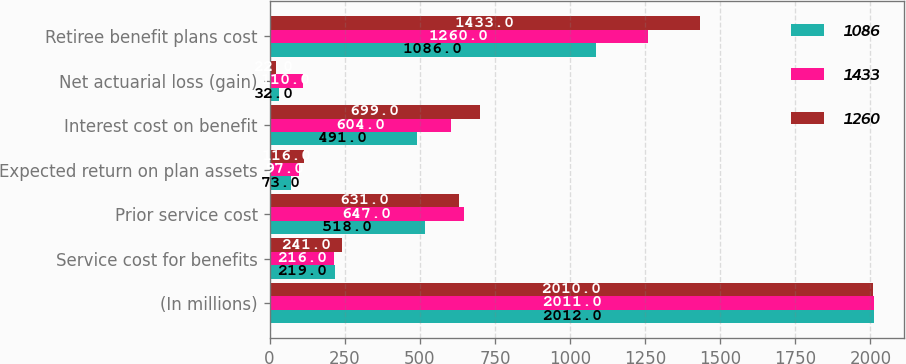<chart> <loc_0><loc_0><loc_500><loc_500><stacked_bar_chart><ecel><fcel>(In millions)<fcel>Service cost for benefits<fcel>Prior service cost<fcel>Expected return on plan assets<fcel>Interest cost on benefit<fcel>Net actuarial loss (gain)<fcel>Retiree benefit plans cost<nl><fcel>1086<fcel>2012<fcel>219<fcel>518<fcel>73<fcel>491<fcel>32<fcel>1086<nl><fcel>1433<fcel>2011<fcel>216<fcel>647<fcel>97<fcel>604<fcel>110<fcel>1260<nl><fcel>1260<fcel>2010<fcel>241<fcel>631<fcel>116<fcel>699<fcel>22<fcel>1433<nl></chart> 